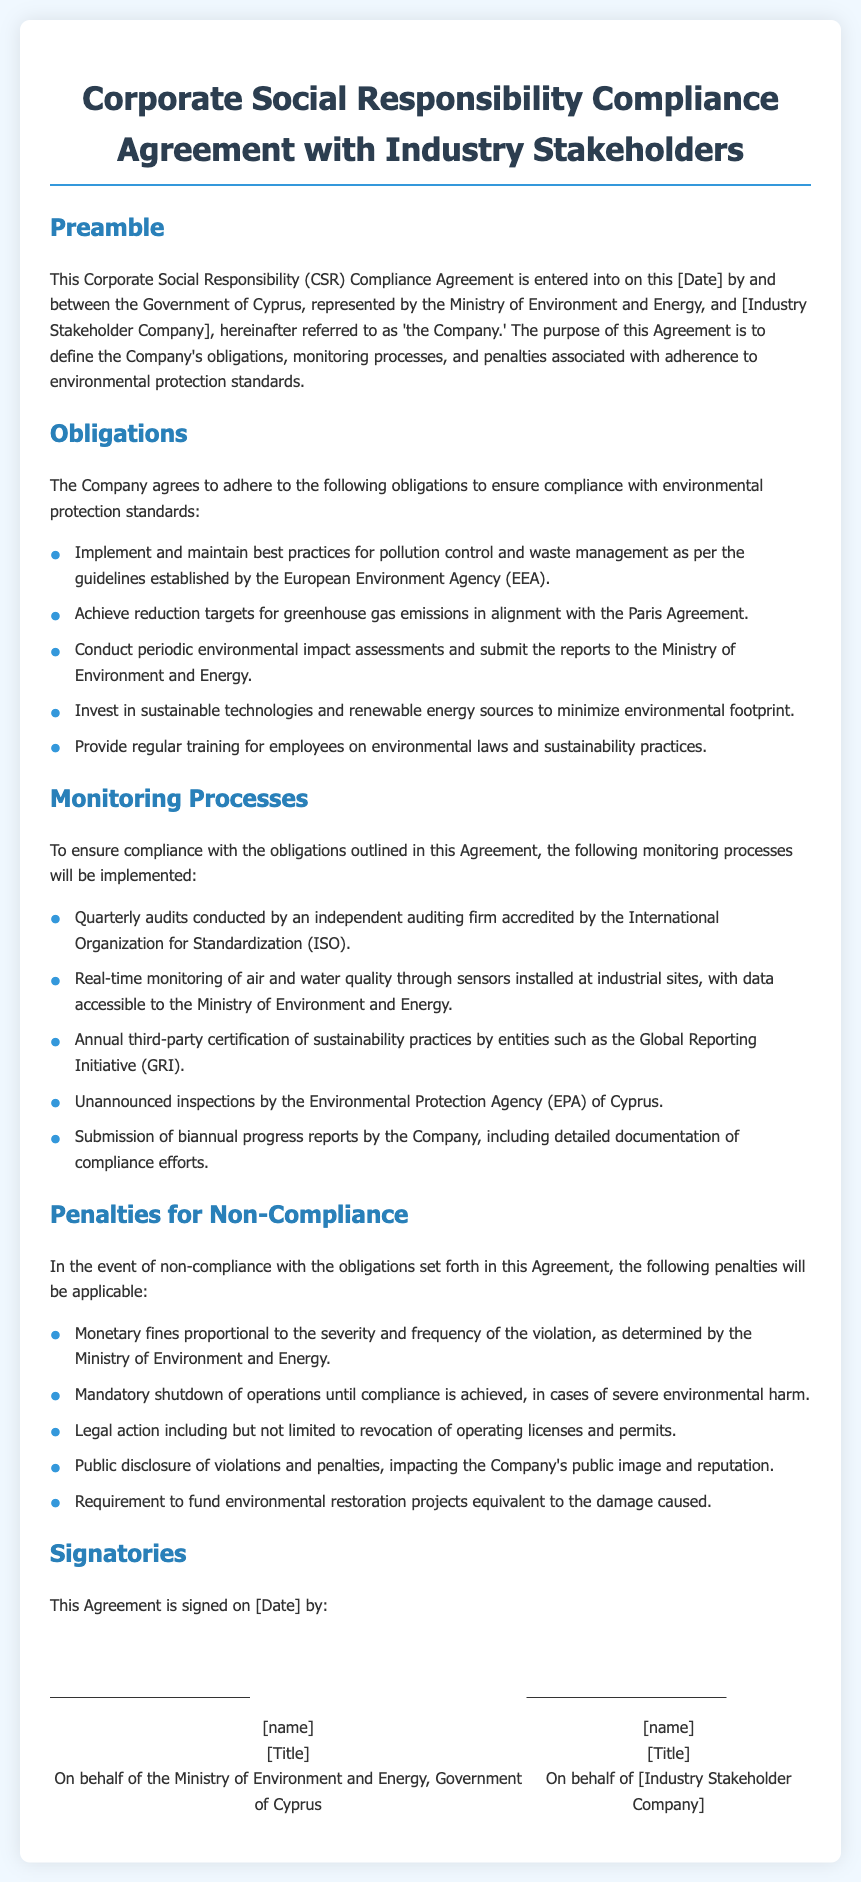What is the title of the document? The title is presented in the heading of the document.
Answer: Corporate Social Responsibility Compliance Agreement with Industry Stakeholders Who represents the Government of Cyprus in this agreement? The representative of the Government of Cyprus is mentioned in the preamble section of the document.
Answer: Ministry of Environment and Energy What is one of the obligations of the Company? This information is listed in the Obligations section of the document.
Answer: Implement and maintain best practices for pollution control and waste management How often are audits conducted according to the monitoring processes? The frequency of the audits is specified in the Monitoring Processes section.
Answer: Quarterly What kind of penalties can be imposed for non-compliance? The document outlines the penalties in a dedicated section.
Answer: Monetary fines Can the Company have its operating licenses revoked? This question pertains to the penalties section of the document.
Answer: Yes What type of inspections does the Environmental Protection Agency conduct? The nature of inspections is outlined under the Monitoring Processes section.
Answer: Unannounced inspections How frequently are progress reports submitted by the Company? The submission frequency can be found in the Monitoring Processes section.
Answer: Biannual 